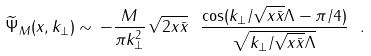Convert formula to latex. <formula><loc_0><loc_0><loc_500><loc_500>\widetilde { \Psi } _ { M } ( x , { k } _ { \perp } ) \sim \, - \frac { M } { \pi k _ { \perp } ^ { 2 } } \, \sqrt { 2 x \bar { x } } \ \frac { \cos ( k _ { \perp } / \sqrt { x \bar { x } } \Lambda - \pi / 4 ) } { \sqrt { k _ { \perp } / \sqrt { x \bar { x } } \Lambda } } \ .</formula> 